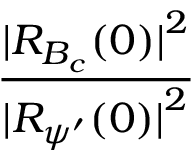<formula> <loc_0><loc_0><loc_500><loc_500>\frac { { | } R _ { B _ { c } } ( 0 ) { | } ^ { 2 } } { { | } R _ { { \psi } ^ { \prime } } ( 0 ) { | } ^ { 2 } }</formula> 